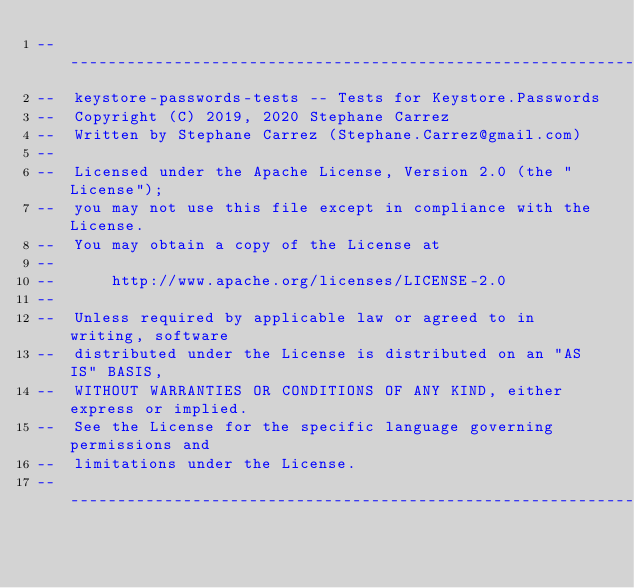Convert code to text. <code><loc_0><loc_0><loc_500><loc_500><_Ada_>-----------------------------------------------------------------------
--  keystore-passwords-tests -- Tests for Keystore.Passwords
--  Copyright (C) 2019, 2020 Stephane Carrez
--  Written by Stephane Carrez (Stephane.Carrez@gmail.com)
--
--  Licensed under the Apache License, Version 2.0 (the "License");
--  you may not use this file except in compliance with the License.
--  You may obtain a copy of the License at
--
--      http://www.apache.org/licenses/LICENSE-2.0
--
--  Unless required by applicable law or agreed to in writing, software
--  distributed under the License is distributed on an "AS IS" BASIS,
--  WITHOUT WARRANTIES OR CONDITIONS OF ANY KIND, either express or implied.
--  See the License for the specific language governing permissions and
--  limitations under the License.
-----------------------------------------------------------------------
</code> 